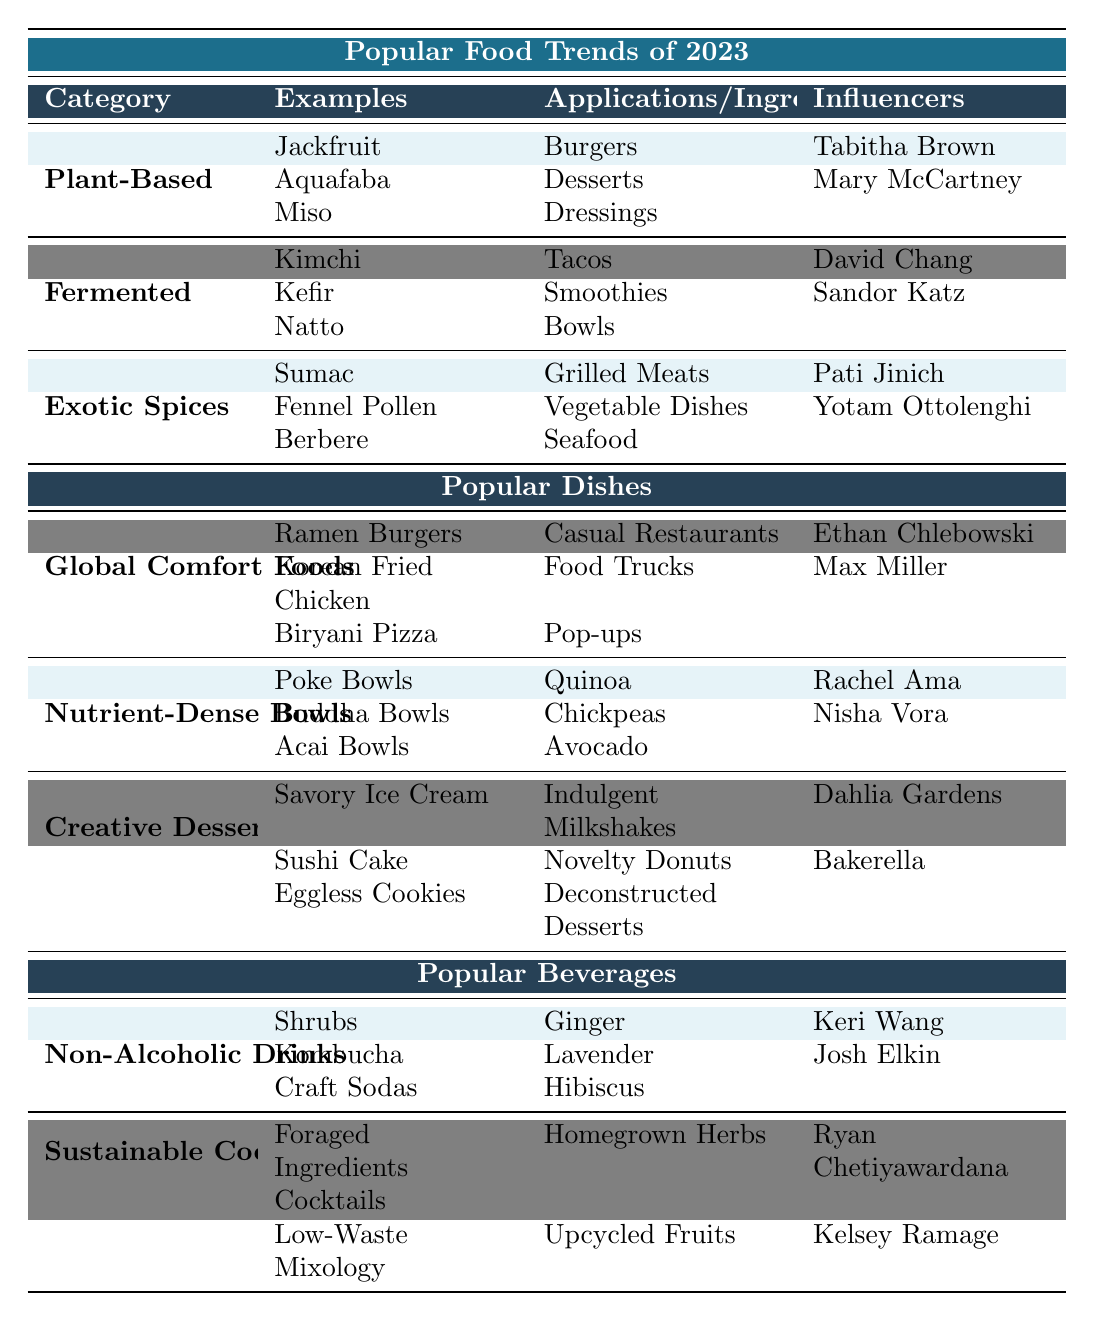What are some examples of plant-based ingredients trending in 2023? The table lists "Jackfruit," "Aquafaba," and "Miso" as examples under the "Plant-Based" category.
Answer: Jackfruit, Aquafaba, Miso Who is an influencer associated with fermented food trends? The table shows "David Chang" and "Sandor Katz" as influencers linked with the "Fermented" category.
Answer: David Chang, Sandor Katz Which dish is a part of global comfort foods? The examples provided for "Global Comfort Foods" include "Ramen Burgers," "Korean Fried Chicken," and "Biryani Pizza."
Answer: Ramen Burgers, Korean Fried Chicken, Biryani Pizza What key ingredients are commonly found in nutrient-dense bowls? The table lists "Quinoa," "Chickpeas," and "Avocado" under "Nutrient-Dense Bowls," indicating these are key ingredients.
Answer: Quinoa, Chickpeas, Avocado Are sustainable cocktails associated with low-waste mixology? The table confirms that "Low-Waste Mixology" is categorized under "Sustainable Cocktails," which indicates a yes.
Answer: Yes Which category includes both savory ice cream and eggless cookies? In the table, "Creative Desserts" contains both "Savory Ice Cream" and "Eggless Cookies" as examples.
Answer: Creative Desserts Can you name one influencer related to exotic spices? According to the table, "Pati Jinich" and "Yotam Ottolenghi" are listed as influencers for the "Exotic Spices" category.
Answer: Pati Jinich, Yotam Ottolenghi What is the common service style for global comfort foods? The service styles listed include "Casual Restaurants," "Food Trucks," and "Pop-ups" for the "Global Comfort Foods."
Answer: Casual Restaurants, Food Trucks, Pop-ups How many examples are provided for non-alcoholic drinks? The table lists three examples: "Shrubs," "Kombucha," and "Craft Sodas," making it a total of three.
Answer: 3 Which category has an example of "Foraged Ingredients Cocktails"? "Sustainable Cocktails" is the category that includes "Foraged Ingredients Cocktails" as an example.
Answer: Sustainable Cocktails How many influencers are associated with nutrient-dense bowls? The table shows two influencers: "Rachel Ama" and "Nisha Vora" connected to "Nutrient-Dense Bowls."
Answer: 2 Which ingredient is used in both sustainable cocktails and non-alcoholic drinks? The table does not show any overlapping ingredients between "Sustainable Cocktails" and "Non-Alcoholic Drinks," making this not applicable.
Answer: None Which dish is associated with food trucks? "Korean Fried Chicken" is mentioned as associated with "Food Trucks" under the "Global Comfort Foods."
Answer: Korean Fried Chicken What is the primary flavor focus for non-alcoholic drinks? The flavors specified for non-alcoholic drinks are "Ginger," "Lavender," and "Hibiscus," indicating the primary flavor focus.
Answer: Ginger, Lavender, Hibiscus Are all examples under "Creative Desserts" considered guilty pleasures? No, not all examples under "Creative Desserts" are listed as guilty pleasures, which makes this statement false.
Answer: No 